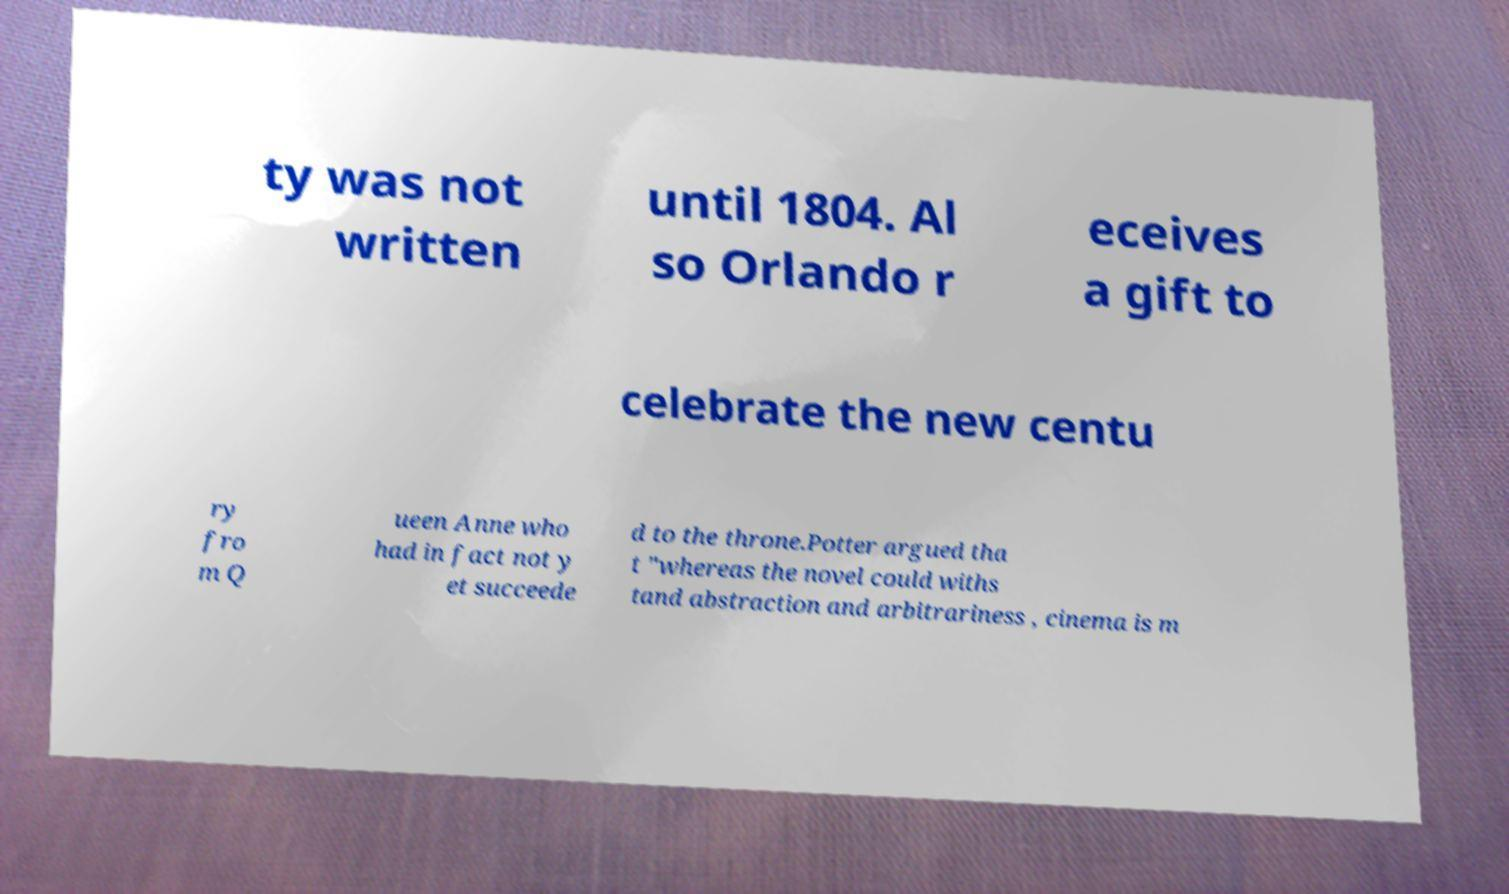What messages or text are displayed in this image? I need them in a readable, typed format. ty was not written until 1804. Al so Orlando r eceives a gift to celebrate the new centu ry fro m Q ueen Anne who had in fact not y et succeede d to the throne.Potter argued tha t "whereas the novel could withs tand abstraction and arbitrariness , cinema is m 